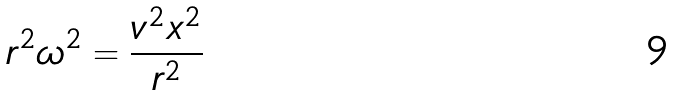<formula> <loc_0><loc_0><loc_500><loc_500>r ^ { 2 } \omega ^ { 2 } = \frac { v ^ { 2 } x ^ { 2 } } { r ^ { 2 } }</formula> 